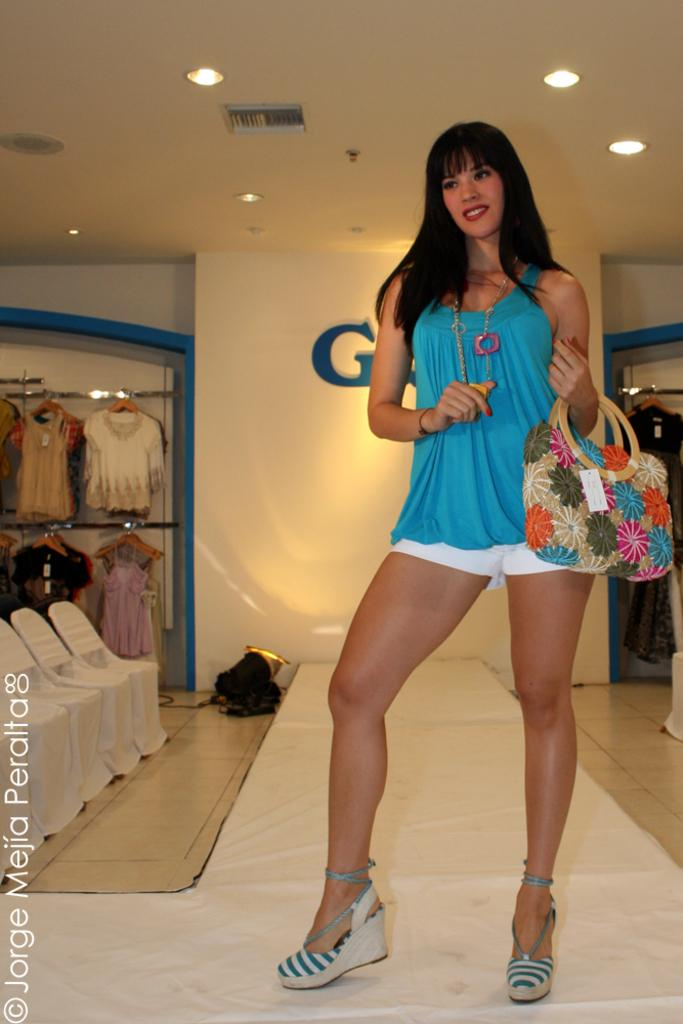What is the person in the image doing? The person is standing in the image. What is the person holding in the image? The person is holding a bag. What can be seen in the background of the image? There is a wall, chairs, and a cloth visible in the background of the image. What is visible on the floor in the image? The floor is visible in the image. What is visible at the top of the image? There are lights visible at the top of the image. What type of song is the cat singing in the image? There is no cat or song present in the image. Is the lettuce being used as a prop in the image? There is no lettuce present in the image. 